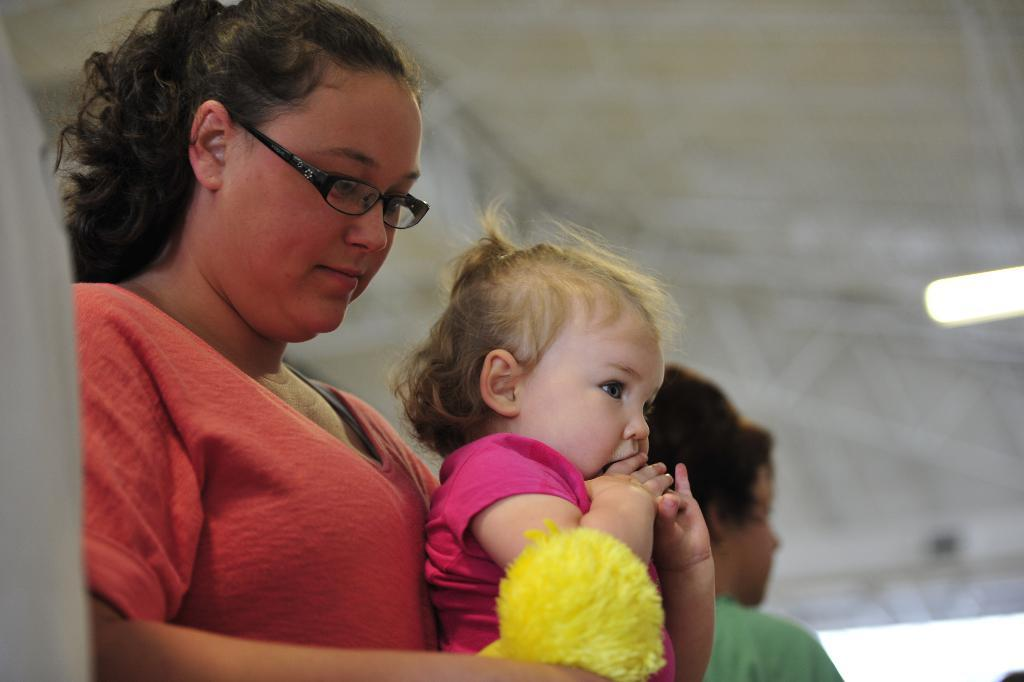What is the main subject of the image? There is a woman in the image. What is the woman wearing? The woman is wearing a t-shirt. What is the woman doing in the image? The woman is holding a baby and looking downwards. Are there any other people in the image? Yes, there is another person in the image. What can be seen on the right side of the image? There is a light on the right side of the image. What type of fruit is being passed between the woman and the other person in the image? There is no fruit present in the image; the woman is holding a baby. 